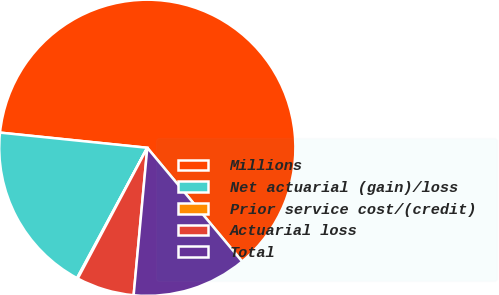Convert chart. <chart><loc_0><loc_0><loc_500><loc_500><pie_chart><fcel>Millions<fcel>Net actuarial (gain)/loss<fcel>Prior service cost/(credit)<fcel>Actuarial loss<fcel>Total<nl><fcel>62.3%<fcel>18.76%<fcel>0.09%<fcel>6.31%<fcel>12.53%<nl></chart> 